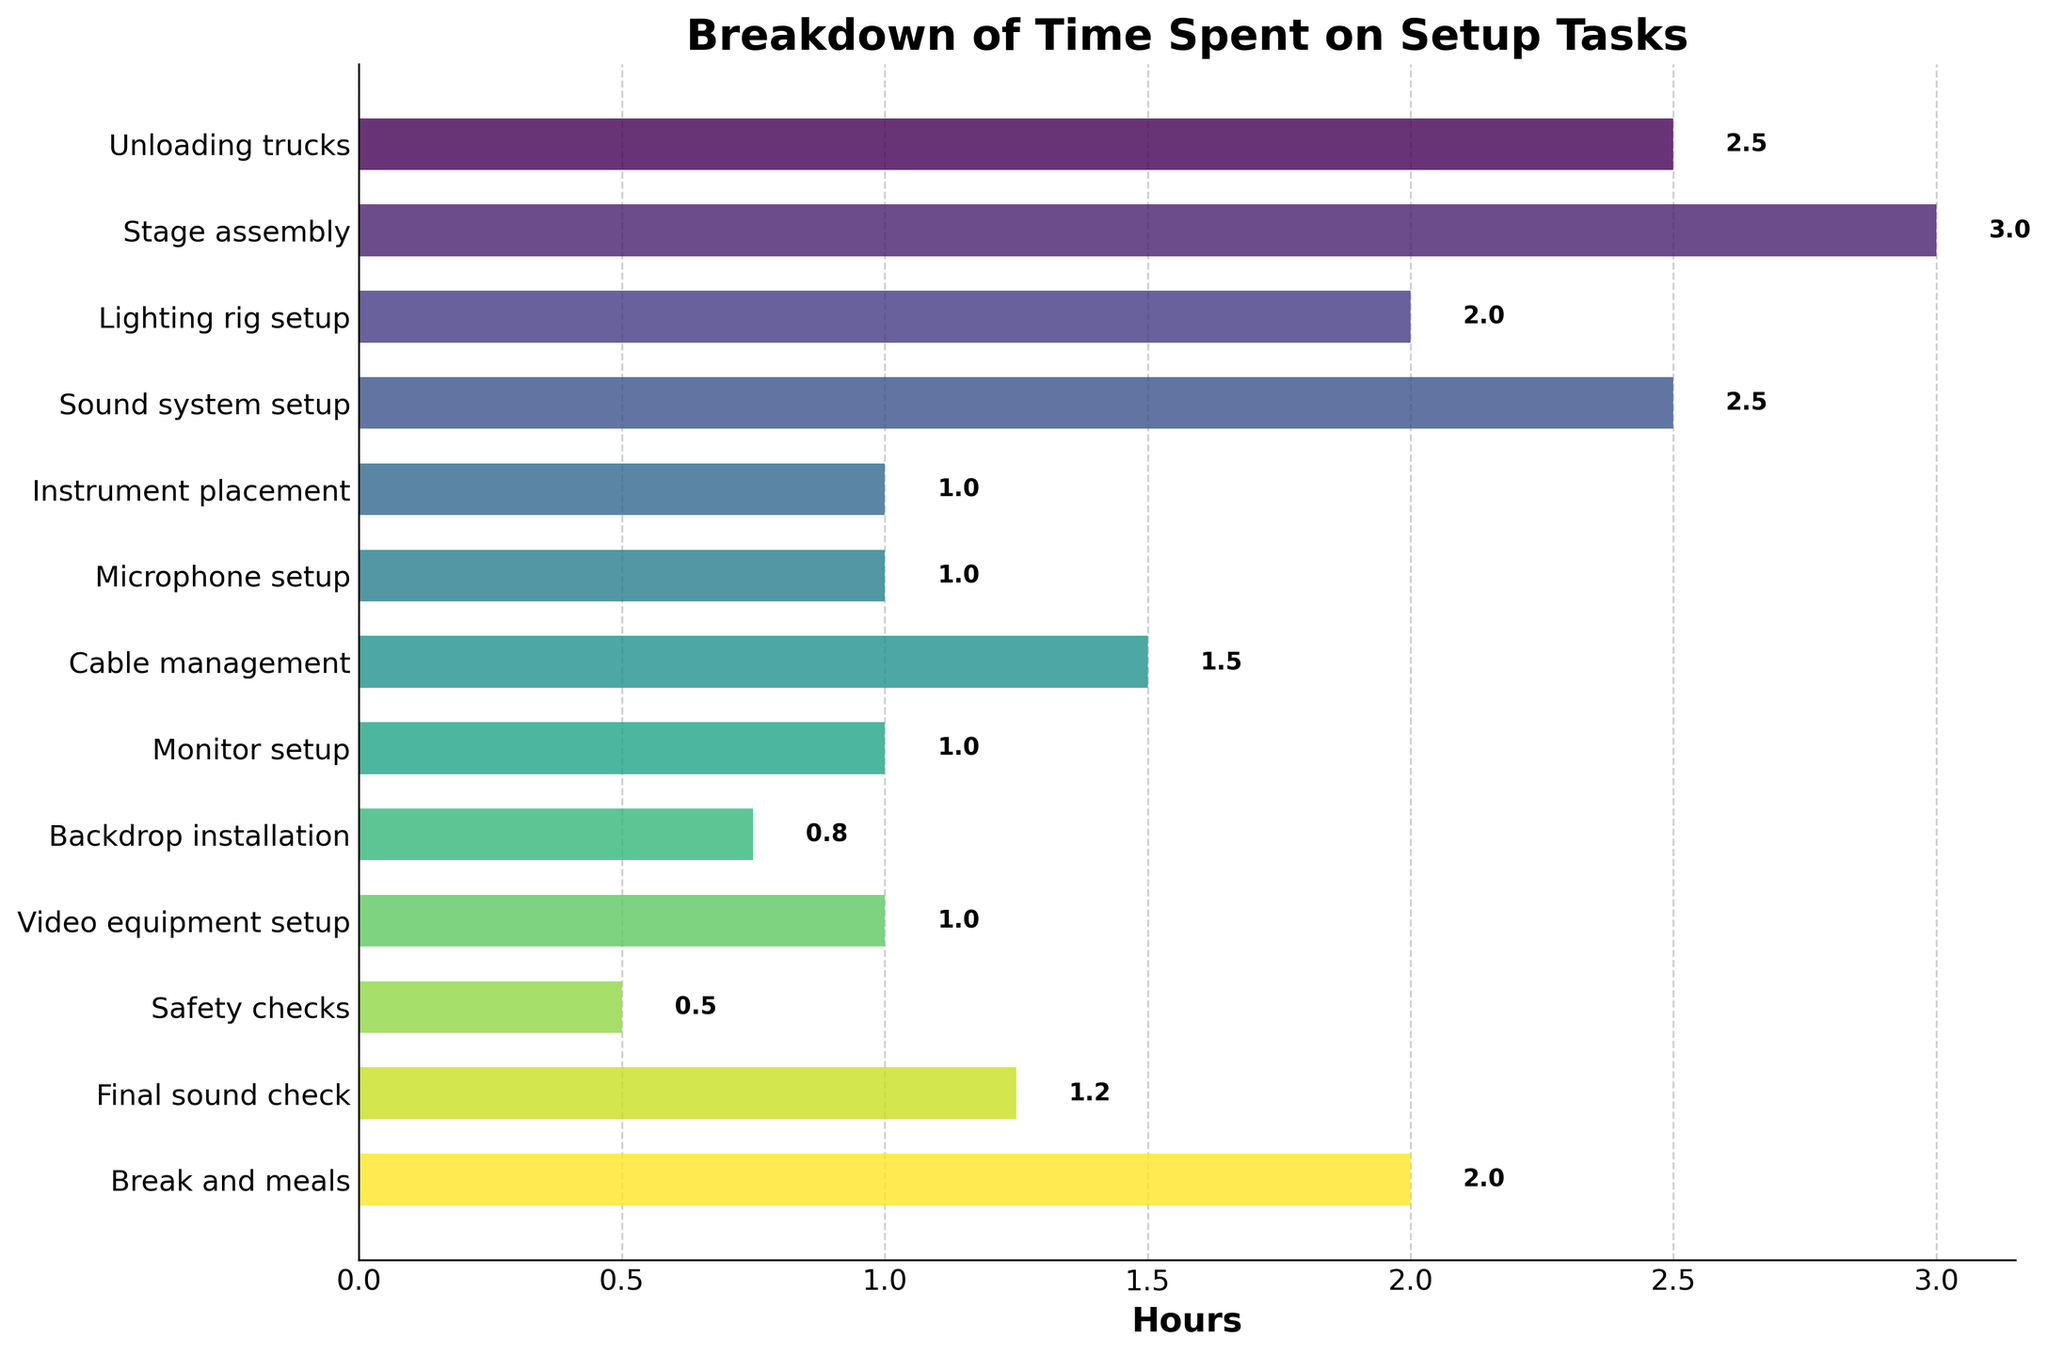What is the total time spent on unloading trucks and stage assembly? To find the total time spent on unloading trucks and stage assembly, add the hours spent on both tasks. Unloading trucks takes 2.5 hours and stage assembly takes 3 hours. Thus, 2.5 + 3 = 5.5 hours
Answer: 5.5 hours How does the time spent on sound system setup compare to the time spent on video equipment setup? The time spent on sound system setup is 2.5 hours and the time spent on video equipment setup is 1 hour. Therefore, sound system setup takes 1.5 hours more than video equipment setup.
Answer: 1.5 hours more Which tasks take equal amounts of time to complete? Observing the bar lengths, we see that sound system setup and unloading trucks both take 2.5 hours, and microphone setup, monitor setup, and video equipment setup each take 1 hour.
Answer: Sound system setup and unloading trucks; Microphone setup, monitor setup, and video equipment setup What is the average time spent on lighting rig setup, cable management, and final sound check? Adding the hours spent on these tasks: 2 (lighting rig setup) + 1.5 (cable management) + 1.25 (final sound check) = 4.75 hours. The average time is 4.75 / 3 = 1.58 (approx)
Answer: 1.58 hours Which task takes the longest, and how much longer is it compared to the shortest task? Stage assembly takes the longest at 3 hours and safety checks take the shortest at 0.5 hours. The difference is 3 - 0.5 = 2.5 hours
Answer: 2.5 hours How much time is spent on tasks related to sound setup (sound system setup, microphone setup, final sound check)? Sum the hours for sound system setup (2.5), microphone setup (1), and final sound check (1.25). Thus, 2.5 + 1 + 1.25 = 4.75 hours
Answer: 4.75 hours What fraction of the total setup time is spent on breaks and meals? The total time spent on all tasks is the sum of all the hours. First, calculate the total time: 2.5 + 3 + 2 + 2.5 + 1 + 1 + 1.5 + 1 + 0.75 + 1 + 0.5 + 1.25 + 2 = 20 hours. Break and meals take 2 hours. So, fraction = 2 / 20 = 1/10 or 0.1
Answer: 0.1 (or 1/10) Which takes more time: unloading trucks plus instrument placement or cable management plus backdrop installation? First, calculate the combined time for each pair. Unloading trucks (2.5) + instrument placement (1) = 3.5 hours. Cable management (1.5) + backdrop installation (0.75) = 2.25 hours. Therefore, unloading trucks and instrument placement take more time.
Answer: Unloading trucks plus instrument placement What's the difference in time between setting up the stage assembly and the microphone setup? The time spent on stage assembly is 3 hours, and the time spent on microphone setup is 1 hour. The difference is 3 - 1 = 2 hours.
Answer: 2 hours 